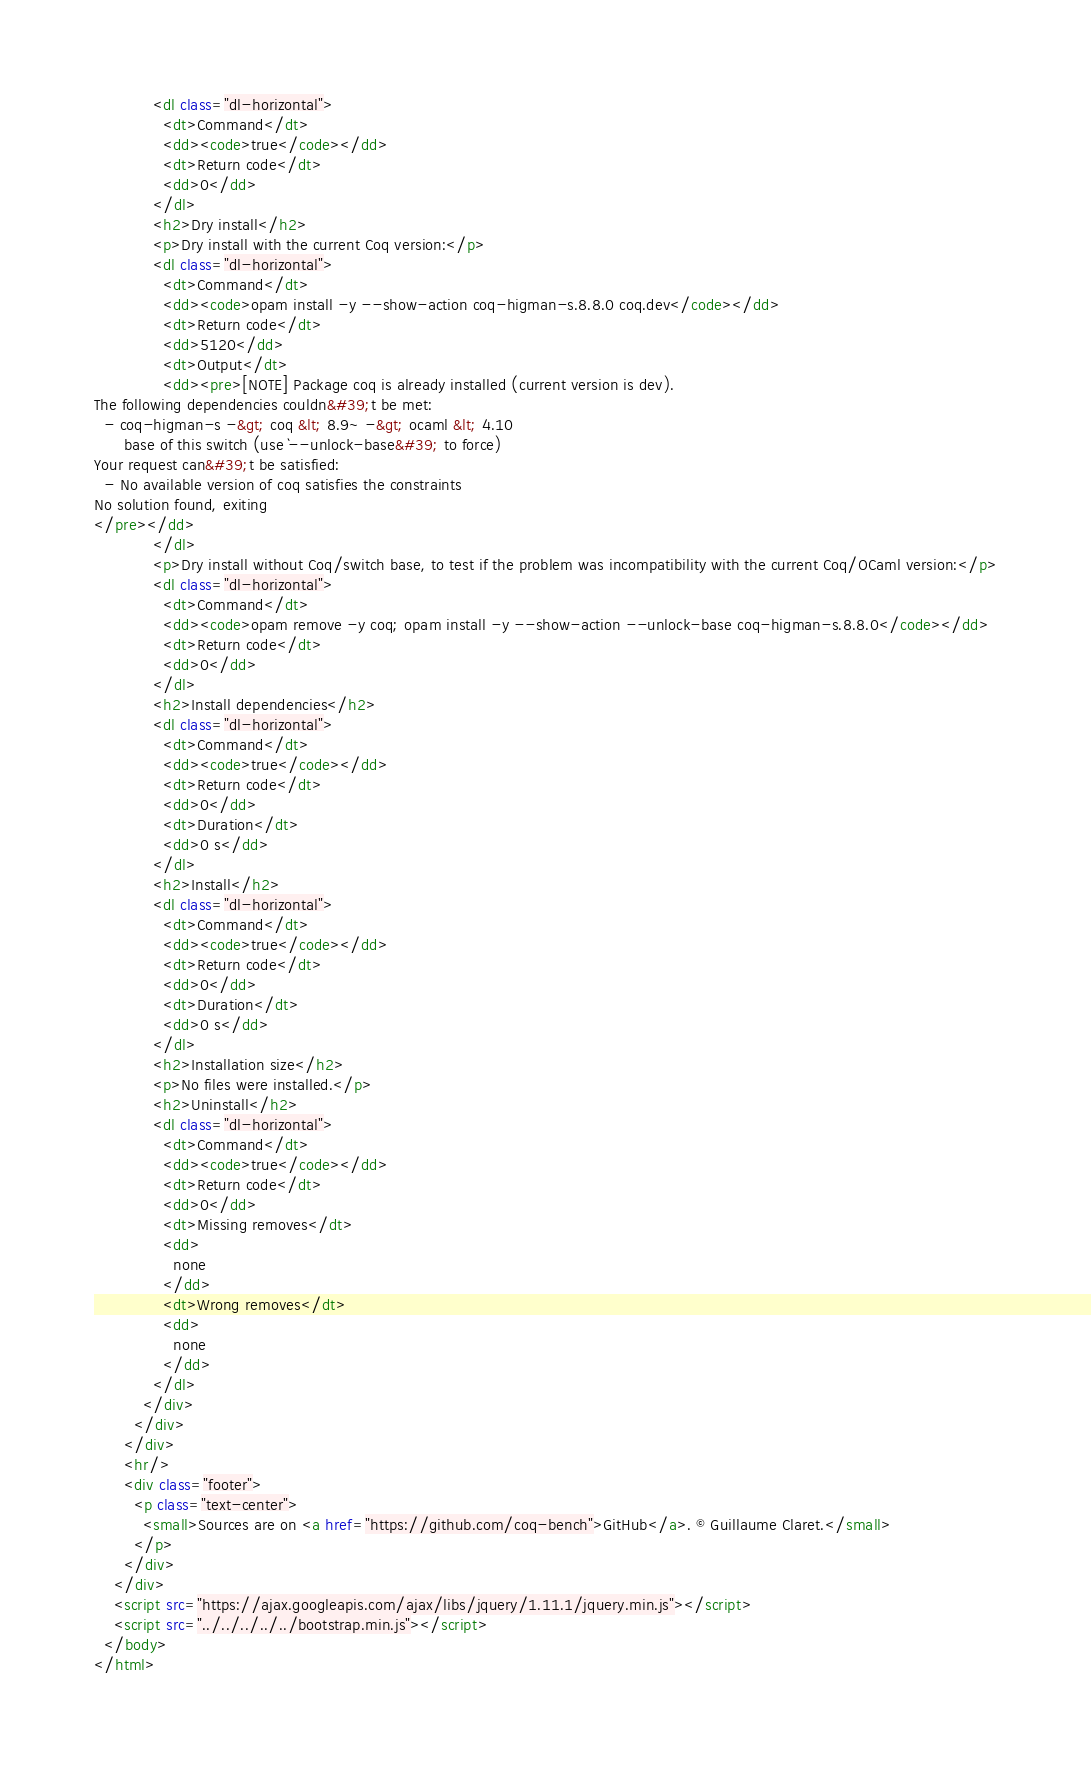Convert code to text. <code><loc_0><loc_0><loc_500><loc_500><_HTML_>            <dl class="dl-horizontal">
              <dt>Command</dt>
              <dd><code>true</code></dd>
              <dt>Return code</dt>
              <dd>0</dd>
            </dl>
            <h2>Dry install</h2>
            <p>Dry install with the current Coq version:</p>
            <dl class="dl-horizontal">
              <dt>Command</dt>
              <dd><code>opam install -y --show-action coq-higman-s.8.8.0 coq.dev</code></dd>
              <dt>Return code</dt>
              <dd>5120</dd>
              <dt>Output</dt>
              <dd><pre>[NOTE] Package coq is already installed (current version is dev).
The following dependencies couldn&#39;t be met:
  - coq-higman-s -&gt; coq &lt; 8.9~ -&gt; ocaml &lt; 4.10
      base of this switch (use `--unlock-base&#39; to force)
Your request can&#39;t be satisfied:
  - No available version of coq satisfies the constraints
No solution found, exiting
</pre></dd>
            </dl>
            <p>Dry install without Coq/switch base, to test if the problem was incompatibility with the current Coq/OCaml version:</p>
            <dl class="dl-horizontal">
              <dt>Command</dt>
              <dd><code>opam remove -y coq; opam install -y --show-action --unlock-base coq-higman-s.8.8.0</code></dd>
              <dt>Return code</dt>
              <dd>0</dd>
            </dl>
            <h2>Install dependencies</h2>
            <dl class="dl-horizontal">
              <dt>Command</dt>
              <dd><code>true</code></dd>
              <dt>Return code</dt>
              <dd>0</dd>
              <dt>Duration</dt>
              <dd>0 s</dd>
            </dl>
            <h2>Install</h2>
            <dl class="dl-horizontal">
              <dt>Command</dt>
              <dd><code>true</code></dd>
              <dt>Return code</dt>
              <dd>0</dd>
              <dt>Duration</dt>
              <dd>0 s</dd>
            </dl>
            <h2>Installation size</h2>
            <p>No files were installed.</p>
            <h2>Uninstall</h2>
            <dl class="dl-horizontal">
              <dt>Command</dt>
              <dd><code>true</code></dd>
              <dt>Return code</dt>
              <dd>0</dd>
              <dt>Missing removes</dt>
              <dd>
                none
              </dd>
              <dt>Wrong removes</dt>
              <dd>
                none
              </dd>
            </dl>
          </div>
        </div>
      </div>
      <hr/>
      <div class="footer">
        <p class="text-center">
          <small>Sources are on <a href="https://github.com/coq-bench">GitHub</a>. © Guillaume Claret.</small>
        </p>
      </div>
    </div>
    <script src="https://ajax.googleapis.com/ajax/libs/jquery/1.11.1/jquery.min.js"></script>
    <script src="../../../../../bootstrap.min.js"></script>
  </body>
</html>
</code> 